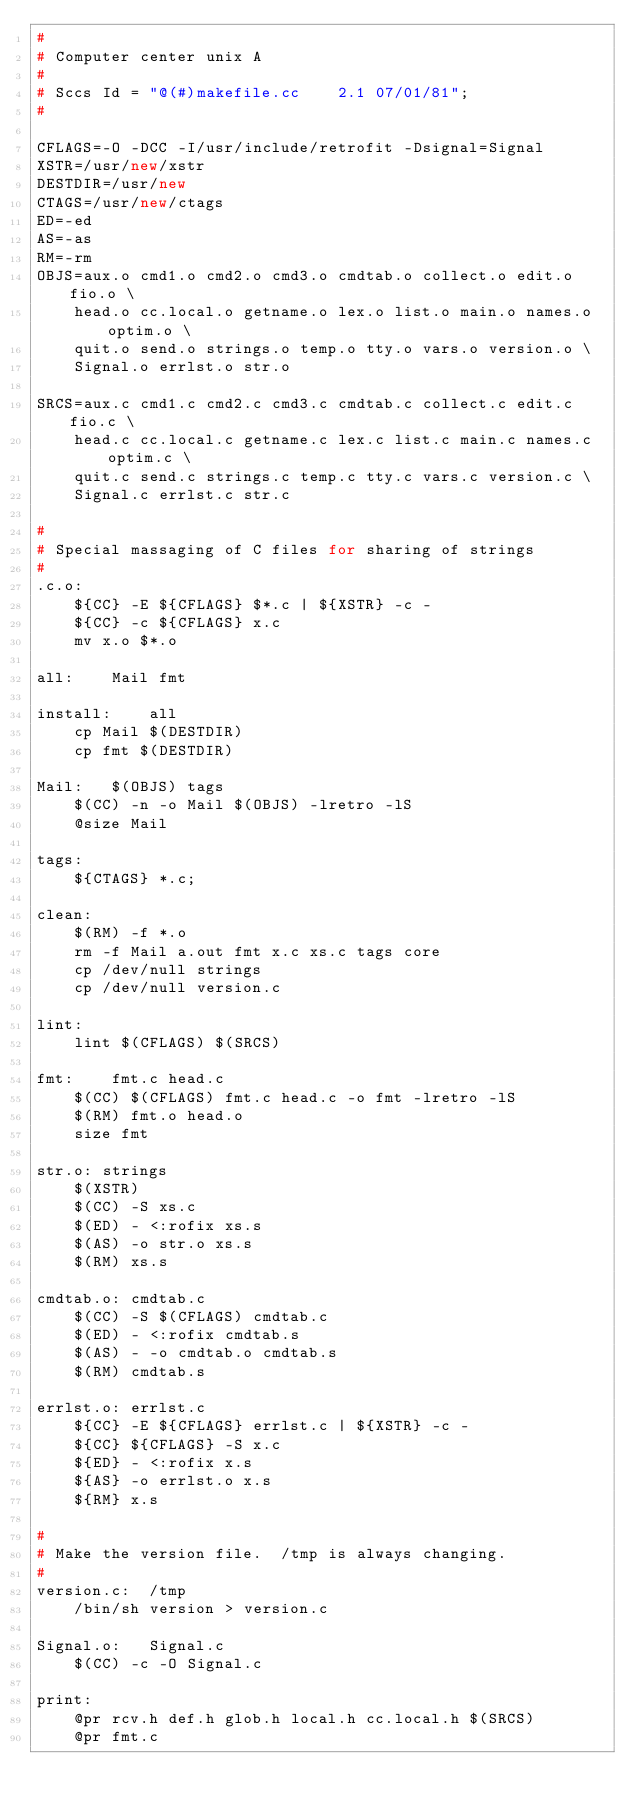<code> <loc_0><loc_0><loc_500><loc_500><_C++_>#
# Computer center unix A
#
# Sccs Id = "@(#)makefile.cc	2.1 07/01/81";
#

CFLAGS=-O -DCC -I/usr/include/retrofit -Dsignal=Signal
XSTR=/usr/new/xstr
DESTDIR=/usr/new
CTAGS=/usr/new/ctags
ED=-ed
AS=-as
RM=-rm
OBJS=aux.o cmd1.o cmd2.o cmd3.o cmdtab.o collect.o edit.o fio.o \
	head.o cc.local.o getname.o lex.o list.o main.o names.o optim.o \
	quit.o send.o strings.o temp.o tty.o vars.o version.o \
	Signal.o errlst.o str.o

SRCS=aux.c cmd1.c cmd2.c cmd3.c cmdtab.c collect.c edit.c fio.c \
	head.c cc.local.c getname.c lex.c list.c main.c names.c optim.c \
	quit.c send.c strings.c temp.c tty.c vars.c version.c \
	Signal.c errlst.c str.c

#
# Special massaging of C files for sharing of strings
#
.c.o:
	${CC} -E ${CFLAGS} $*.c | ${XSTR} -c -
	${CC} -c ${CFLAGS} x.c 
	mv x.o $*.o

all:	Mail fmt

install:	all
	cp Mail $(DESTDIR)
	cp fmt $(DESTDIR)

Mail:	$(OBJS) tags
	$(CC) -n -o Mail $(OBJS) -lretro -lS
	@size Mail

tags:
	${CTAGS} *.c;

clean:
	$(RM) -f *.o
	rm -f Mail a.out fmt x.c xs.c tags core
	cp /dev/null strings
	cp /dev/null version.c

lint:
	lint $(CFLAGS) $(SRCS)

fmt:	fmt.c head.c
	$(CC) $(CFLAGS) fmt.c head.c -o fmt -lretro -lS
	$(RM) fmt.o head.o
	size fmt

str.o: strings
	$(XSTR)
	$(CC) -S xs.c
	$(ED) - <:rofix xs.s
	$(AS) -o str.o xs.s
	$(RM) xs.s

cmdtab.o: cmdtab.c
	$(CC) -S $(CFLAGS) cmdtab.c
	$(ED) - <:rofix cmdtab.s
	$(AS) - -o cmdtab.o cmdtab.s
	$(RM) cmdtab.s

errlst.o: errlst.c
	${CC} -E ${CFLAGS} errlst.c | ${XSTR} -c -
	${CC} ${CFLAGS} -S x.c
	${ED} - <:rofix x.s
	${AS} -o errlst.o x.s
	${RM} x.s

#
# Make the version file.  /tmp is always changing.
#
version.c:	/tmp
	/bin/sh version > version.c

Signal.o:	Signal.c
	$(CC) -c -O Signal.c

print:
	@pr rcv.h def.h glob.h local.h cc.local.h $(SRCS)
	@pr fmt.c
</code> 